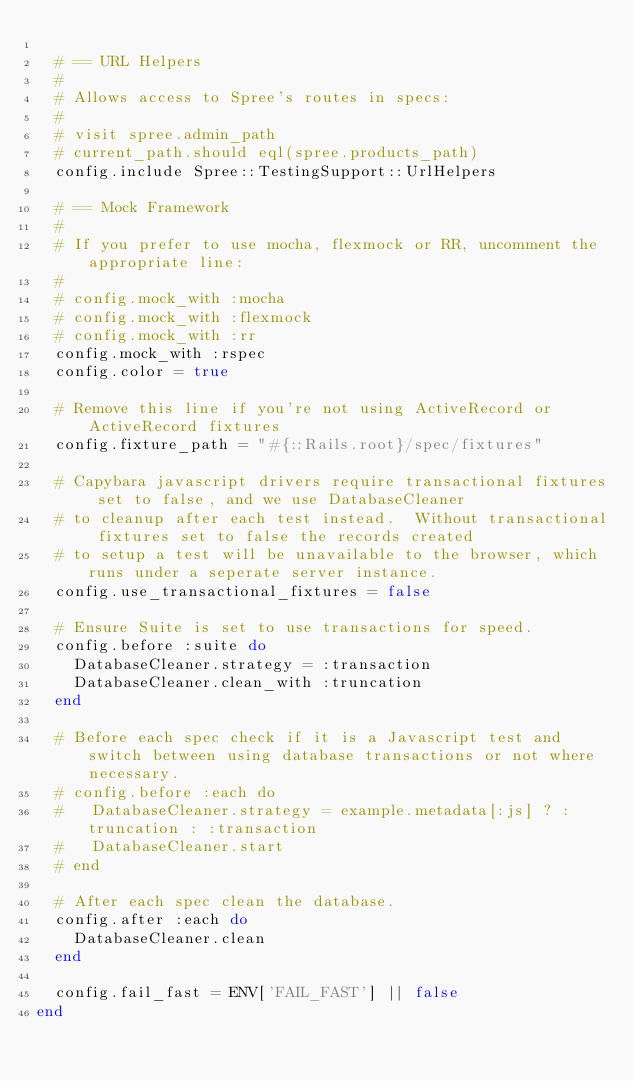<code> <loc_0><loc_0><loc_500><loc_500><_Ruby_>
  # == URL Helpers
  #
  # Allows access to Spree's routes in specs:
  #
  # visit spree.admin_path
  # current_path.should eql(spree.products_path)
  config.include Spree::TestingSupport::UrlHelpers

  # == Mock Framework
  #
  # If you prefer to use mocha, flexmock or RR, uncomment the appropriate line:
  #
  # config.mock_with :mocha
  # config.mock_with :flexmock
  # config.mock_with :rr
  config.mock_with :rspec
  config.color = true

  # Remove this line if you're not using ActiveRecord or ActiveRecord fixtures
  config.fixture_path = "#{::Rails.root}/spec/fixtures"

  # Capybara javascript drivers require transactional fixtures set to false, and we use DatabaseCleaner
  # to cleanup after each test instead.  Without transactional fixtures set to false the records created
  # to setup a test will be unavailable to the browser, which runs under a seperate server instance.
  config.use_transactional_fixtures = false

  # Ensure Suite is set to use transactions for speed.
  config.before :suite do
    DatabaseCleaner.strategy = :transaction
    DatabaseCleaner.clean_with :truncation
  end

  # Before each spec check if it is a Javascript test and switch between using database transactions or not where necessary.
  # config.before :each do
  #   DatabaseCleaner.strategy = example.metadata[:js] ? :truncation : :transaction
  #   DatabaseCleaner.start
  # end

  # After each spec clean the database.
  config.after :each do
    DatabaseCleaner.clean
  end

  config.fail_fast = ENV['FAIL_FAST'] || false
end
</code> 